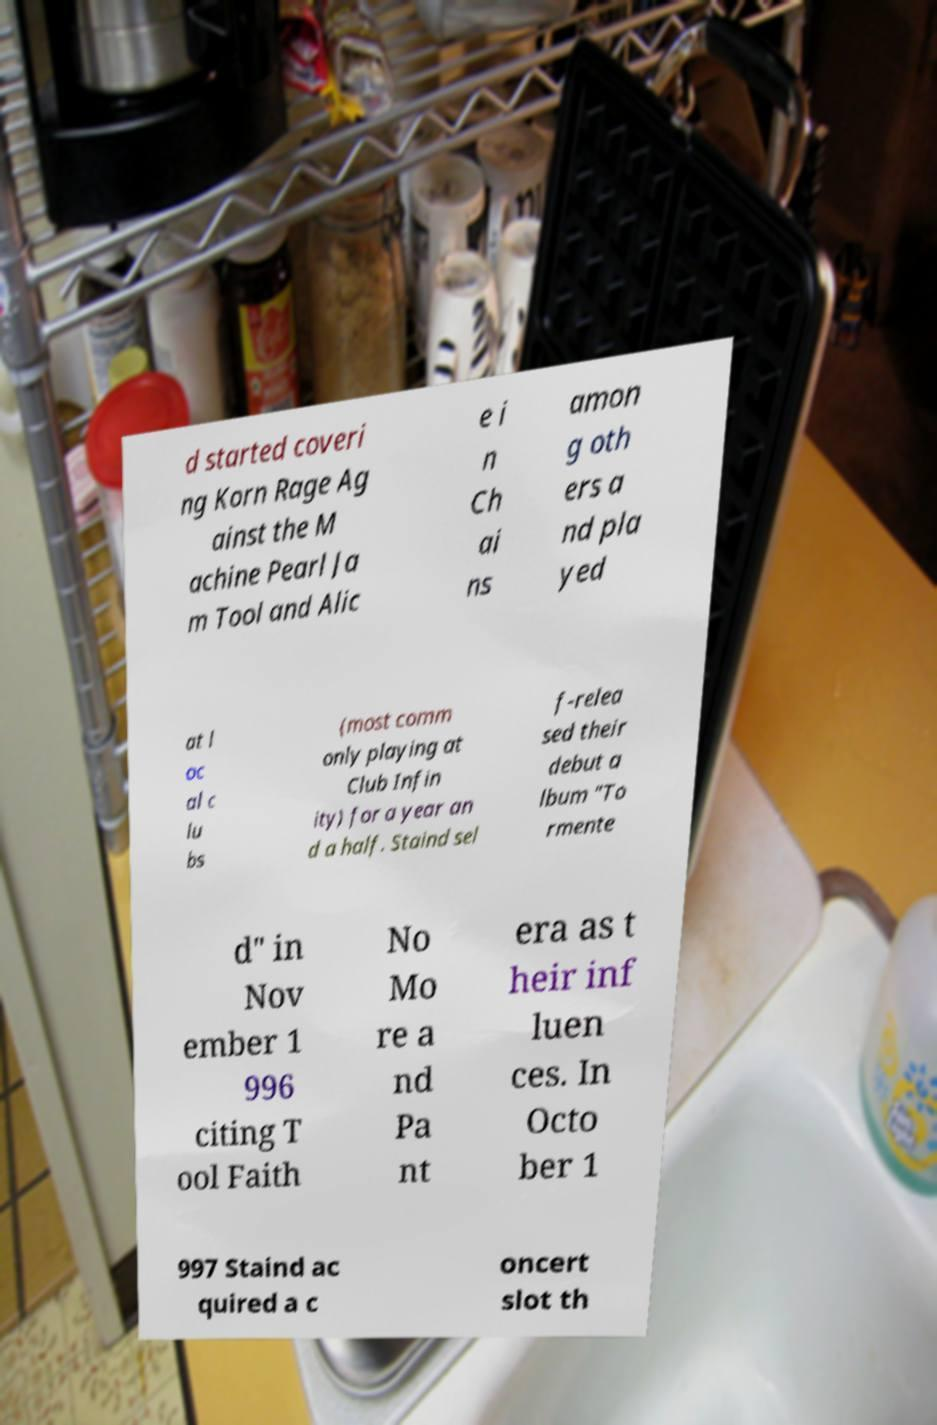Can you accurately transcribe the text from the provided image for me? d started coveri ng Korn Rage Ag ainst the M achine Pearl Ja m Tool and Alic e i n Ch ai ns amon g oth ers a nd pla yed at l oc al c lu bs (most comm only playing at Club Infin ity) for a year an d a half. Staind sel f-relea sed their debut a lbum "To rmente d" in Nov ember 1 996 citing T ool Faith No Mo re a nd Pa nt era as t heir inf luen ces. In Octo ber 1 997 Staind ac quired a c oncert slot th 